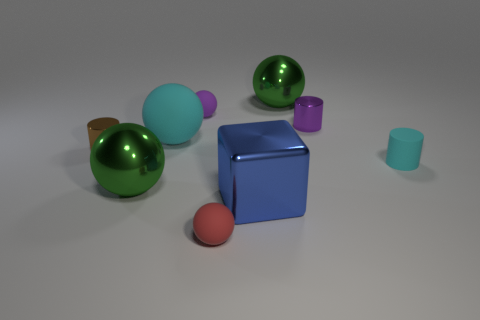Subtract 2 balls. How many balls are left? 3 Subtract all gray spheres. Subtract all purple cylinders. How many spheres are left? 5 Add 1 small metal cylinders. How many objects exist? 10 Subtract all cylinders. How many objects are left? 6 Subtract 2 green balls. How many objects are left? 7 Subtract all red rubber balls. Subtract all tiny brown cylinders. How many objects are left? 7 Add 3 cyan rubber cylinders. How many cyan rubber cylinders are left? 4 Add 7 green rubber spheres. How many green rubber spheres exist? 7 